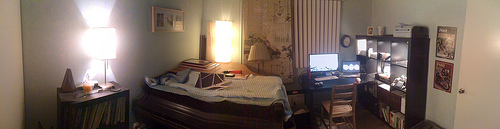Please provide a short description for this region: [0.64, 0.53, 0.72, 0.62]. The coordinates highlight a comfortable, adjustable office chair with armrests and a high back, positioned in front of a desk cluttered with various objects and personal items. 